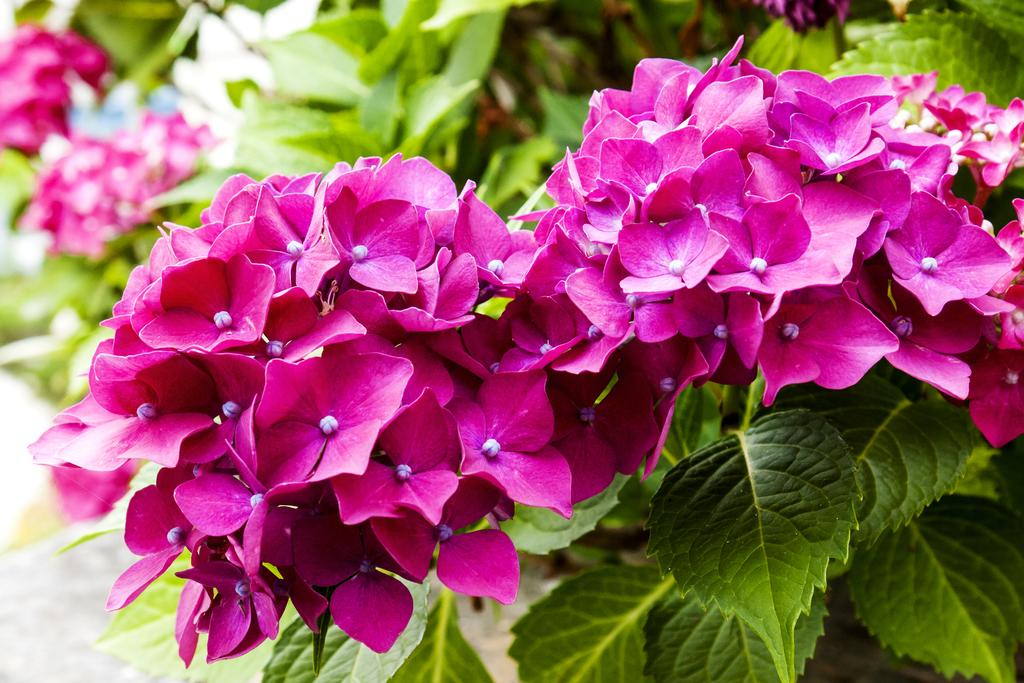What type of living organisms can be seen in the image? There are flowers in the image. What colors are the flowers? The flowers are pink and white in color. Where are the flowers located? The flowers are on a plant. What color is the plant? The plant is green in color. How would you describe the background of the image? The background of the image is blurry. How many eyes can be seen on the flowers in the image? Flowers do not have eyes, so there are no eyes visible on the flowers in the image. 